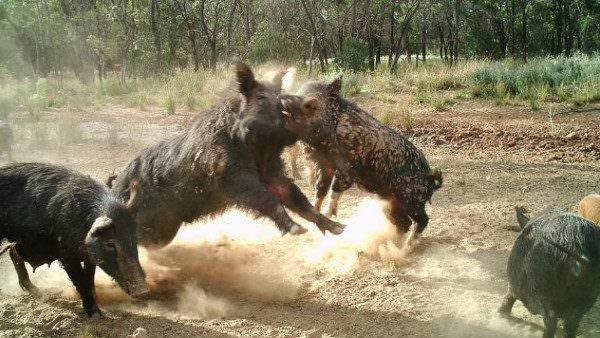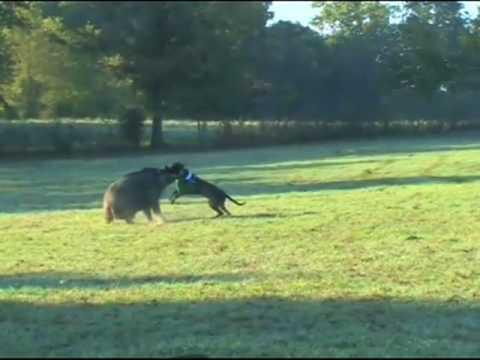The first image is the image on the left, the second image is the image on the right. Given the left and right images, does the statement "There are at least four black boars outside." hold true? Answer yes or no. Yes. The first image is the image on the left, the second image is the image on the right. Considering the images on both sides, is "In at least one of the images, one dog is facing off with one hog." valid? Answer yes or no. Yes. 